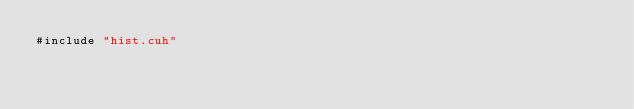<code> <loc_0><loc_0><loc_500><loc_500><_Cuda_>#include "hist.cuh"</code> 